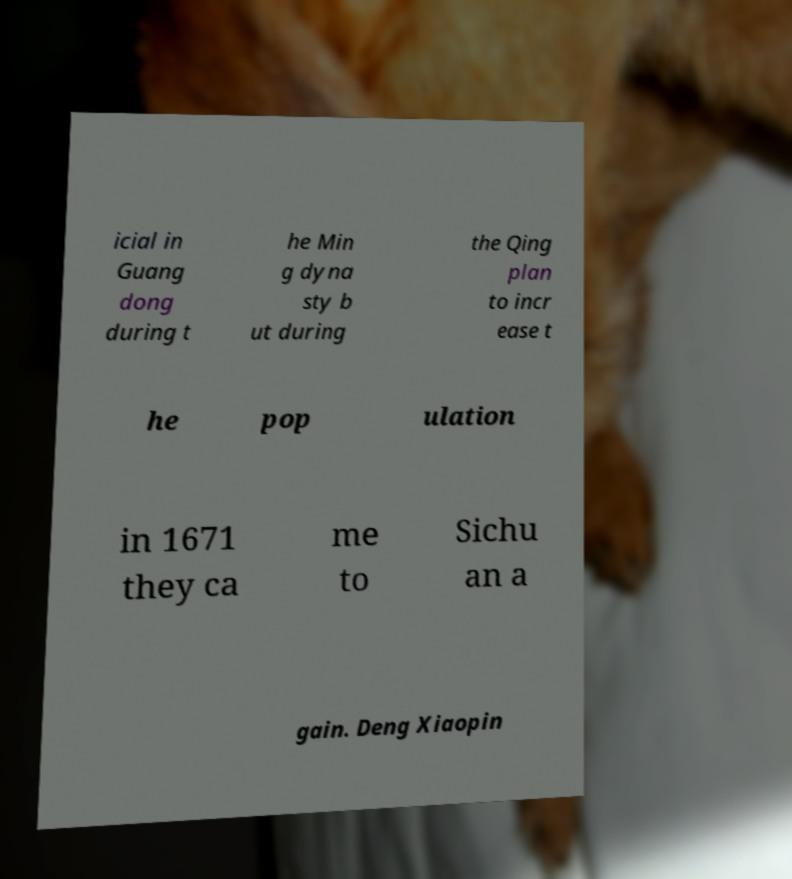What messages or text are displayed in this image? I need them in a readable, typed format. icial in Guang dong during t he Min g dyna sty b ut during the Qing plan to incr ease t he pop ulation in 1671 they ca me to Sichu an a gain. Deng Xiaopin 